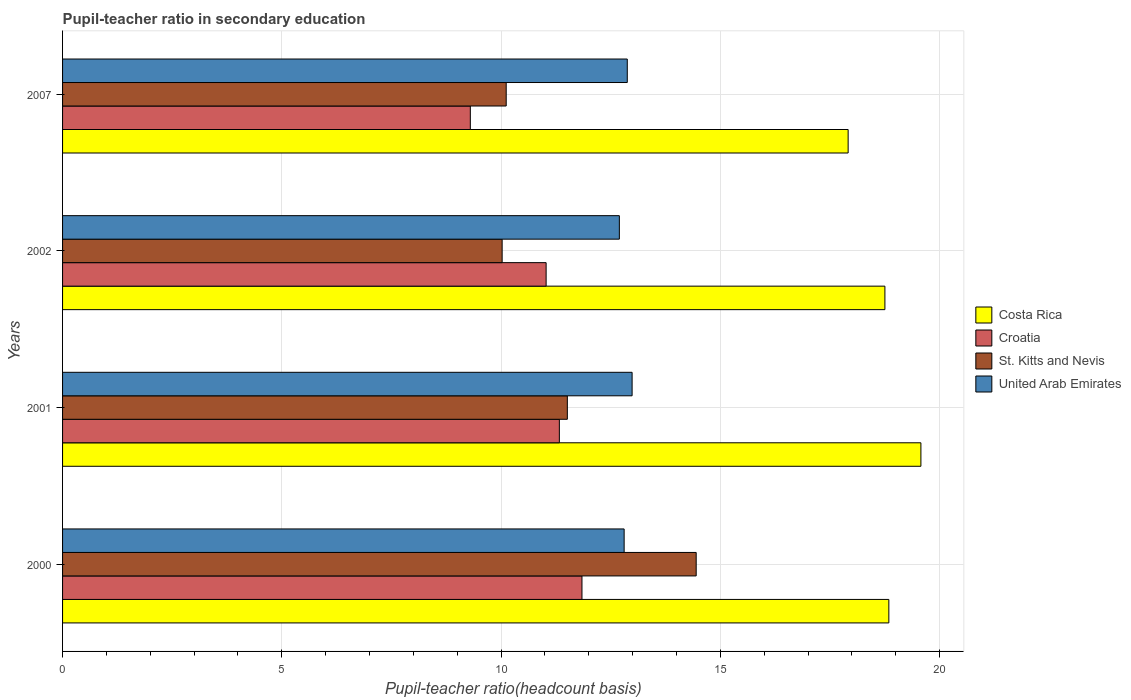How many different coloured bars are there?
Give a very brief answer. 4. How many bars are there on the 4th tick from the bottom?
Keep it short and to the point. 4. What is the label of the 3rd group of bars from the top?
Ensure brevity in your answer.  2001. In how many cases, is the number of bars for a given year not equal to the number of legend labels?
Provide a succinct answer. 0. What is the pupil-teacher ratio in secondary education in St. Kitts and Nevis in 2007?
Your answer should be compact. 10.12. Across all years, what is the maximum pupil-teacher ratio in secondary education in Croatia?
Your answer should be compact. 11.84. Across all years, what is the minimum pupil-teacher ratio in secondary education in St. Kitts and Nevis?
Your response must be concise. 10.02. What is the total pupil-teacher ratio in secondary education in United Arab Emirates in the graph?
Your answer should be compact. 51.37. What is the difference between the pupil-teacher ratio in secondary education in Costa Rica in 2000 and that in 2007?
Make the answer very short. 0.93. What is the difference between the pupil-teacher ratio in secondary education in United Arab Emirates in 2007 and the pupil-teacher ratio in secondary education in Croatia in 2001?
Ensure brevity in your answer.  1.55. What is the average pupil-teacher ratio in secondary education in Costa Rica per year?
Provide a short and direct response. 18.77. In the year 2001, what is the difference between the pupil-teacher ratio in secondary education in United Arab Emirates and pupil-teacher ratio in secondary education in St. Kitts and Nevis?
Your answer should be very brief. 1.48. In how many years, is the pupil-teacher ratio in secondary education in United Arab Emirates greater than 4 ?
Your answer should be compact. 4. What is the ratio of the pupil-teacher ratio in secondary education in Croatia in 2000 to that in 2007?
Provide a short and direct response. 1.27. Is the pupil-teacher ratio in secondary education in United Arab Emirates in 2000 less than that in 2002?
Provide a succinct answer. No. Is the difference between the pupil-teacher ratio in secondary education in United Arab Emirates in 2001 and 2007 greater than the difference between the pupil-teacher ratio in secondary education in St. Kitts and Nevis in 2001 and 2007?
Your answer should be compact. No. What is the difference between the highest and the second highest pupil-teacher ratio in secondary education in United Arab Emirates?
Your answer should be compact. 0.11. What is the difference between the highest and the lowest pupil-teacher ratio in secondary education in United Arab Emirates?
Keep it short and to the point. 0.29. In how many years, is the pupil-teacher ratio in secondary education in United Arab Emirates greater than the average pupil-teacher ratio in secondary education in United Arab Emirates taken over all years?
Your response must be concise. 2. Is it the case that in every year, the sum of the pupil-teacher ratio in secondary education in United Arab Emirates and pupil-teacher ratio in secondary education in Croatia is greater than the sum of pupil-teacher ratio in secondary education in St. Kitts and Nevis and pupil-teacher ratio in secondary education in Costa Rica?
Provide a short and direct response. Yes. What does the 1st bar from the top in 2001 represents?
Your response must be concise. United Arab Emirates. What does the 3rd bar from the bottom in 2001 represents?
Provide a short and direct response. St. Kitts and Nevis. Is it the case that in every year, the sum of the pupil-teacher ratio in secondary education in Costa Rica and pupil-teacher ratio in secondary education in Croatia is greater than the pupil-teacher ratio in secondary education in United Arab Emirates?
Your response must be concise. Yes. How many years are there in the graph?
Ensure brevity in your answer.  4. Does the graph contain grids?
Offer a terse response. Yes. How are the legend labels stacked?
Ensure brevity in your answer.  Vertical. What is the title of the graph?
Provide a short and direct response. Pupil-teacher ratio in secondary education. Does "Croatia" appear as one of the legend labels in the graph?
Offer a terse response. Yes. What is the label or title of the X-axis?
Offer a very short reply. Pupil-teacher ratio(headcount basis). What is the label or title of the Y-axis?
Offer a terse response. Years. What is the Pupil-teacher ratio(headcount basis) of Costa Rica in 2000?
Your answer should be compact. 18.84. What is the Pupil-teacher ratio(headcount basis) in Croatia in 2000?
Provide a short and direct response. 11.84. What is the Pupil-teacher ratio(headcount basis) in St. Kitts and Nevis in 2000?
Keep it short and to the point. 14.45. What is the Pupil-teacher ratio(headcount basis) of United Arab Emirates in 2000?
Your answer should be compact. 12.81. What is the Pupil-teacher ratio(headcount basis) of Costa Rica in 2001?
Your answer should be compact. 19.57. What is the Pupil-teacher ratio(headcount basis) in Croatia in 2001?
Provide a succinct answer. 11.33. What is the Pupil-teacher ratio(headcount basis) of St. Kitts and Nevis in 2001?
Offer a very short reply. 11.51. What is the Pupil-teacher ratio(headcount basis) in United Arab Emirates in 2001?
Your response must be concise. 12.99. What is the Pupil-teacher ratio(headcount basis) in Costa Rica in 2002?
Offer a terse response. 18.75. What is the Pupil-teacher ratio(headcount basis) in Croatia in 2002?
Your response must be concise. 11.03. What is the Pupil-teacher ratio(headcount basis) in St. Kitts and Nevis in 2002?
Give a very brief answer. 10.02. What is the Pupil-teacher ratio(headcount basis) of United Arab Emirates in 2002?
Offer a very short reply. 12.7. What is the Pupil-teacher ratio(headcount basis) in Costa Rica in 2007?
Keep it short and to the point. 17.91. What is the Pupil-teacher ratio(headcount basis) of Croatia in 2007?
Offer a terse response. 9.3. What is the Pupil-teacher ratio(headcount basis) in St. Kitts and Nevis in 2007?
Ensure brevity in your answer.  10.12. What is the Pupil-teacher ratio(headcount basis) in United Arab Emirates in 2007?
Provide a short and direct response. 12.88. Across all years, what is the maximum Pupil-teacher ratio(headcount basis) of Costa Rica?
Provide a succinct answer. 19.57. Across all years, what is the maximum Pupil-teacher ratio(headcount basis) of Croatia?
Provide a succinct answer. 11.84. Across all years, what is the maximum Pupil-teacher ratio(headcount basis) in St. Kitts and Nevis?
Make the answer very short. 14.45. Across all years, what is the maximum Pupil-teacher ratio(headcount basis) of United Arab Emirates?
Offer a very short reply. 12.99. Across all years, what is the minimum Pupil-teacher ratio(headcount basis) of Costa Rica?
Ensure brevity in your answer.  17.91. Across all years, what is the minimum Pupil-teacher ratio(headcount basis) of Croatia?
Give a very brief answer. 9.3. Across all years, what is the minimum Pupil-teacher ratio(headcount basis) of St. Kitts and Nevis?
Your answer should be compact. 10.02. Across all years, what is the minimum Pupil-teacher ratio(headcount basis) in United Arab Emirates?
Your answer should be compact. 12.7. What is the total Pupil-teacher ratio(headcount basis) of Costa Rica in the graph?
Give a very brief answer. 75.08. What is the total Pupil-teacher ratio(headcount basis) in Croatia in the graph?
Provide a succinct answer. 43.5. What is the total Pupil-teacher ratio(headcount basis) of St. Kitts and Nevis in the graph?
Ensure brevity in your answer.  46.1. What is the total Pupil-teacher ratio(headcount basis) of United Arab Emirates in the graph?
Make the answer very short. 51.37. What is the difference between the Pupil-teacher ratio(headcount basis) of Costa Rica in 2000 and that in 2001?
Offer a terse response. -0.73. What is the difference between the Pupil-teacher ratio(headcount basis) in Croatia in 2000 and that in 2001?
Offer a terse response. 0.52. What is the difference between the Pupil-teacher ratio(headcount basis) of St. Kitts and Nevis in 2000 and that in 2001?
Keep it short and to the point. 2.94. What is the difference between the Pupil-teacher ratio(headcount basis) in United Arab Emirates in 2000 and that in 2001?
Offer a terse response. -0.18. What is the difference between the Pupil-teacher ratio(headcount basis) of Costa Rica in 2000 and that in 2002?
Your response must be concise. 0.09. What is the difference between the Pupil-teacher ratio(headcount basis) of Croatia in 2000 and that in 2002?
Make the answer very short. 0.82. What is the difference between the Pupil-teacher ratio(headcount basis) of St. Kitts and Nevis in 2000 and that in 2002?
Keep it short and to the point. 4.42. What is the difference between the Pupil-teacher ratio(headcount basis) of United Arab Emirates in 2000 and that in 2002?
Your response must be concise. 0.11. What is the difference between the Pupil-teacher ratio(headcount basis) of Costa Rica in 2000 and that in 2007?
Keep it short and to the point. 0.93. What is the difference between the Pupil-teacher ratio(headcount basis) in Croatia in 2000 and that in 2007?
Your response must be concise. 2.55. What is the difference between the Pupil-teacher ratio(headcount basis) in St. Kitts and Nevis in 2000 and that in 2007?
Your answer should be very brief. 4.33. What is the difference between the Pupil-teacher ratio(headcount basis) in United Arab Emirates in 2000 and that in 2007?
Ensure brevity in your answer.  -0.07. What is the difference between the Pupil-teacher ratio(headcount basis) of Costa Rica in 2001 and that in 2002?
Make the answer very short. 0.82. What is the difference between the Pupil-teacher ratio(headcount basis) of Croatia in 2001 and that in 2002?
Ensure brevity in your answer.  0.3. What is the difference between the Pupil-teacher ratio(headcount basis) in St. Kitts and Nevis in 2001 and that in 2002?
Your answer should be compact. 1.49. What is the difference between the Pupil-teacher ratio(headcount basis) in United Arab Emirates in 2001 and that in 2002?
Ensure brevity in your answer.  0.29. What is the difference between the Pupil-teacher ratio(headcount basis) of Costa Rica in 2001 and that in 2007?
Ensure brevity in your answer.  1.66. What is the difference between the Pupil-teacher ratio(headcount basis) in Croatia in 2001 and that in 2007?
Offer a terse response. 2.03. What is the difference between the Pupil-teacher ratio(headcount basis) of St. Kitts and Nevis in 2001 and that in 2007?
Provide a succinct answer. 1.39. What is the difference between the Pupil-teacher ratio(headcount basis) in United Arab Emirates in 2001 and that in 2007?
Provide a short and direct response. 0.11. What is the difference between the Pupil-teacher ratio(headcount basis) of Costa Rica in 2002 and that in 2007?
Offer a terse response. 0.84. What is the difference between the Pupil-teacher ratio(headcount basis) of Croatia in 2002 and that in 2007?
Offer a very short reply. 1.73. What is the difference between the Pupil-teacher ratio(headcount basis) in St. Kitts and Nevis in 2002 and that in 2007?
Your answer should be very brief. -0.09. What is the difference between the Pupil-teacher ratio(headcount basis) of United Arab Emirates in 2002 and that in 2007?
Make the answer very short. -0.18. What is the difference between the Pupil-teacher ratio(headcount basis) of Costa Rica in 2000 and the Pupil-teacher ratio(headcount basis) of Croatia in 2001?
Your answer should be very brief. 7.51. What is the difference between the Pupil-teacher ratio(headcount basis) in Costa Rica in 2000 and the Pupil-teacher ratio(headcount basis) in St. Kitts and Nevis in 2001?
Provide a short and direct response. 7.33. What is the difference between the Pupil-teacher ratio(headcount basis) of Costa Rica in 2000 and the Pupil-teacher ratio(headcount basis) of United Arab Emirates in 2001?
Your response must be concise. 5.85. What is the difference between the Pupil-teacher ratio(headcount basis) in Croatia in 2000 and the Pupil-teacher ratio(headcount basis) in St. Kitts and Nevis in 2001?
Ensure brevity in your answer.  0.33. What is the difference between the Pupil-teacher ratio(headcount basis) of Croatia in 2000 and the Pupil-teacher ratio(headcount basis) of United Arab Emirates in 2001?
Make the answer very short. -1.14. What is the difference between the Pupil-teacher ratio(headcount basis) of St. Kitts and Nevis in 2000 and the Pupil-teacher ratio(headcount basis) of United Arab Emirates in 2001?
Make the answer very short. 1.46. What is the difference between the Pupil-teacher ratio(headcount basis) of Costa Rica in 2000 and the Pupil-teacher ratio(headcount basis) of Croatia in 2002?
Provide a short and direct response. 7.82. What is the difference between the Pupil-teacher ratio(headcount basis) of Costa Rica in 2000 and the Pupil-teacher ratio(headcount basis) of St. Kitts and Nevis in 2002?
Offer a terse response. 8.82. What is the difference between the Pupil-teacher ratio(headcount basis) of Costa Rica in 2000 and the Pupil-teacher ratio(headcount basis) of United Arab Emirates in 2002?
Make the answer very short. 6.14. What is the difference between the Pupil-teacher ratio(headcount basis) in Croatia in 2000 and the Pupil-teacher ratio(headcount basis) in St. Kitts and Nevis in 2002?
Ensure brevity in your answer.  1.82. What is the difference between the Pupil-teacher ratio(headcount basis) in Croatia in 2000 and the Pupil-teacher ratio(headcount basis) in United Arab Emirates in 2002?
Make the answer very short. -0.85. What is the difference between the Pupil-teacher ratio(headcount basis) of St. Kitts and Nevis in 2000 and the Pupil-teacher ratio(headcount basis) of United Arab Emirates in 2002?
Keep it short and to the point. 1.75. What is the difference between the Pupil-teacher ratio(headcount basis) of Costa Rica in 2000 and the Pupil-teacher ratio(headcount basis) of Croatia in 2007?
Make the answer very short. 9.54. What is the difference between the Pupil-teacher ratio(headcount basis) in Costa Rica in 2000 and the Pupil-teacher ratio(headcount basis) in St. Kitts and Nevis in 2007?
Offer a very short reply. 8.73. What is the difference between the Pupil-teacher ratio(headcount basis) of Costa Rica in 2000 and the Pupil-teacher ratio(headcount basis) of United Arab Emirates in 2007?
Keep it short and to the point. 5.96. What is the difference between the Pupil-teacher ratio(headcount basis) of Croatia in 2000 and the Pupil-teacher ratio(headcount basis) of St. Kitts and Nevis in 2007?
Your response must be concise. 1.73. What is the difference between the Pupil-teacher ratio(headcount basis) in Croatia in 2000 and the Pupil-teacher ratio(headcount basis) in United Arab Emirates in 2007?
Provide a succinct answer. -1.03. What is the difference between the Pupil-teacher ratio(headcount basis) of St. Kitts and Nevis in 2000 and the Pupil-teacher ratio(headcount basis) of United Arab Emirates in 2007?
Make the answer very short. 1.57. What is the difference between the Pupil-teacher ratio(headcount basis) in Costa Rica in 2001 and the Pupil-teacher ratio(headcount basis) in Croatia in 2002?
Provide a short and direct response. 8.55. What is the difference between the Pupil-teacher ratio(headcount basis) in Costa Rica in 2001 and the Pupil-teacher ratio(headcount basis) in St. Kitts and Nevis in 2002?
Offer a terse response. 9.55. What is the difference between the Pupil-teacher ratio(headcount basis) of Costa Rica in 2001 and the Pupil-teacher ratio(headcount basis) of United Arab Emirates in 2002?
Keep it short and to the point. 6.88. What is the difference between the Pupil-teacher ratio(headcount basis) in Croatia in 2001 and the Pupil-teacher ratio(headcount basis) in St. Kitts and Nevis in 2002?
Keep it short and to the point. 1.3. What is the difference between the Pupil-teacher ratio(headcount basis) of Croatia in 2001 and the Pupil-teacher ratio(headcount basis) of United Arab Emirates in 2002?
Make the answer very short. -1.37. What is the difference between the Pupil-teacher ratio(headcount basis) of St. Kitts and Nevis in 2001 and the Pupil-teacher ratio(headcount basis) of United Arab Emirates in 2002?
Ensure brevity in your answer.  -1.19. What is the difference between the Pupil-teacher ratio(headcount basis) of Costa Rica in 2001 and the Pupil-teacher ratio(headcount basis) of Croatia in 2007?
Your answer should be very brief. 10.27. What is the difference between the Pupil-teacher ratio(headcount basis) in Costa Rica in 2001 and the Pupil-teacher ratio(headcount basis) in St. Kitts and Nevis in 2007?
Offer a very short reply. 9.46. What is the difference between the Pupil-teacher ratio(headcount basis) of Costa Rica in 2001 and the Pupil-teacher ratio(headcount basis) of United Arab Emirates in 2007?
Your answer should be very brief. 6.7. What is the difference between the Pupil-teacher ratio(headcount basis) of Croatia in 2001 and the Pupil-teacher ratio(headcount basis) of St. Kitts and Nevis in 2007?
Provide a short and direct response. 1.21. What is the difference between the Pupil-teacher ratio(headcount basis) in Croatia in 2001 and the Pupil-teacher ratio(headcount basis) in United Arab Emirates in 2007?
Keep it short and to the point. -1.55. What is the difference between the Pupil-teacher ratio(headcount basis) in St. Kitts and Nevis in 2001 and the Pupil-teacher ratio(headcount basis) in United Arab Emirates in 2007?
Your response must be concise. -1.37. What is the difference between the Pupil-teacher ratio(headcount basis) of Costa Rica in 2002 and the Pupil-teacher ratio(headcount basis) of Croatia in 2007?
Give a very brief answer. 9.45. What is the difference between the Pupil-teacher ratio(headcount basis) in Costa Rica in 2002 and the Pupil-teacher ratio(headcount basis) in St. Kitts and Nevis in 2007?
Make the answer very short. 8.64. What is the difference between the Pupil-teacher ratio(headcount basis) in Costa Rica in 2002 and the Pupil-teacher ratio(headcount basis) in United Arab Emirates in 2007?
Your response must be concise. 5.87. What is the difference between the Pupil-teacher ratio(headcount basis) in Croatia in 2002 and the Pupil-teacher ratio(headcount basis) in St. Kitts and Nevis in 2007?
Give a very brief answer. 0.91. What is the difference between the Pupil-teacher ratio(headcount basis) in Croatia in 2002 and the Pupil-teacher ratio(headcount basis) in United Arab Emirates in 2007?
Your answer should be very brief. -1.85. What is the difference between the Pupil-teacher ratio(headcount basis) in St. Kitts and Nevis in 2002 and the Pupil-teacher ratio(headcount basis) in United Arab Emirates in 2007?
Offer a terse response. -2.85. What is the average Pupil-teacher ratio(headcount basis) of Costa Rica per year?
Your response must be concise. 18.77. What is the average Pupil-teacher ratio(headcount basis) in Croatia per year?
Provide a succinct answer. 10.87. What is the average Pupil-teacher ratio(headcount basis) of St. Kitts and Nevis per year?
Make the answer very short. 11.52. What is the average Pupil-teacher ratio(headcount basis) in United Arab Emirates per year?
Keep it short and to the point. 12.84. In the year 2000, what is the difference between the Pupil-teacher ratio(headcount basis) in Costa Rica and Pupil-teacher ratio(headcount basis) in Croatia?
Your answer should be very brief. 7. In the year 2000, what is the difference between the Pupil-teacher ratio(headcount basis) of Costa Rica and Pupil-teacher ratio(headcount basis) of St. Kitts and Nevis?
Make the answer very short. 4.39. In the year 2000, what is the difference between the Pupil-teacher ratio(headcount basis) in Costa Rica and Pupil-teacher ratio(headcount basis) in United Arab Emirates?
Provide a short and direct response. 6.04. In the year 2000, what is the difference between the Pupil-teacher ratio(headcount basis) of Croatia and Pupil-teacher ratio(headcount basis) of St. Kitts and Nevis?
Your answer should be very brief. -2.6. In the year 2000, what is the difference between the Pupil-teacher ratio(headcount basis) in Croatia and Pupil-teacher ratio(headcount basis) in United Arab Emirates?
Your response must be concise. -0.96. In the year 2000, what is the difference between the Pupil-teacher ratio(headcount basis) of St. Kitts and Nevis and Pupil-teacher ratio(headcount basis) of United Arab Emirates?
Keep it short and to the point. 1.64. In the year 2001, what is the difference between the Pupil-teacher ratio(headcount basis) of Costa Rica and Pupil-teacher ratio(headcount basis) of Croatia?
Provide a succinct answer. 8.24. In the year 2001, what is the difference between the Pupil-teacher ratio(headcount basis) in Costa Rica and Pupil-teacher ratio(headcount basis) in St. Kitts and Nevis?
Offer a terse response. 8.06. In the year 2001, what is the difference between the Pupil-teacher ratio(headcount basis) in Costa Rica and Pupil-teacher ratio(headcount basis) in United Arab Emirates?
Keep it short and to the point. 6.59. In the year 2001, what is the difference between the Pupil-teacher ratio(headcount basis) in Croatia and Pupil-teacher ratio(headcount basis) in St. Kitts and Nevis?
Offer a very short reply. -0.18. In the year 2001, what is the difference between the Pupil-teacher ratio(headcount basis) of Croatia and Pupil-teacher ratio(headcount basis) of United Arab Emirates?
Your answer should be very brief. -1.66. In the year 2001, what is the difference between the Pupil-teacher ratio(headcount basis) in St. Kitts and Nevis and Pupil-teacher ratio(headcount basis) in United Arab Emirates?
Ensure brevity in your answer.  -1.48. In the year 2002, what is the difference between the Pupil-teacher ratio(headcount basis) of Costa Rica and Pupil-teacher ratio(headcount basis) of Croatia?
Offer a terse response. 7.73. In the year 2002, what is the difference between the Pupil-teacher ratio(headcount basis) of Costa Rica and Pupil-teacher ratio(headcount basis) of St. Kitts and Nevis?
Your answer should be very brief. 8.73. In the year 2002, what is the difference between the Pupil-teacher ratio(headcount basis) in Costa Rica and Pupil-teacher ratio(headcount basis) in United Arab Emirates?
Make the answer very short. 6.06. In the year 2002, what is the difference between the Pupil-teacher ratio(headcount basis) of Croatia and Pupil-teacher ratio(headcount basis) of United Arab Emirates?
Keep it short and to the point. -1.67. In the year 2002, what is the difference between the Pupil-teacher ratio(headcount basis) in St. Kitts and Nevis and Pupil-teacher ratio(headcount basis) in United Arab Emirates?
Ensure brevity in your answer.  -2.67. In the year 2007, what is the difference between the Pupil-teacher ratio(headcount basis) of Costa Rica and Pupil-teacher ratio(headcount basis) of Croatia?
Provide a succinct answer. 8.62. In the year 2007, what is the difference between the Pupil-teacher ratio(headcount basis) in Costa Rica and Pupil-teacher ratio(headcount basis) in St. Kitts and Nevis?
Offer a very short reply. 7.8. In the year 2007, what is the difference between the Pupil-teacher ratio(headcount basis) of Costa Rica and Pupil-teacher ratio(headcount basis) of United Arab Emirates?
Ensure brevity in your answer.  5.04. In the year 2007, what is the difference between the Pupil-teacher ratio(headcount basis) in Croatia and Pupil-teacher ratio(headcount basis) in St. Kitts and Nevis?
Make the answer very short. -0.82. In the year 2007, what is the difference between the Pupil-teacher ratio(headcount basis) of Croatia and Pupil-teacher ratio(headcount basis) of United Arab Emirates?
Keep it short and to the point. -3.58. In the year 2007, what is the difference between the Pupil-teacher ratio(headcount basis) in St. Kitts and Nevis and Pupil-teacher ratio(headcount basis) in United Arab Emirates?
Ensure brevity in your answer.  -2.76. What is the ratio of the Pupil-teacher ratio(headcount basis) of Costa Rica in 2000 to that in 2001?
Provide a succinct answer. 0.96. What is the ratio of the Pupil-teacher ratio(headcount basis) of Croatia in 2000 to that in 2001?
Offer a terse response. 1.05. What is the ratio of the Pupil-teacher ratio(headcount basis) of St. Kitts and Nevis in 2000 to that in 2001?
Provide a succinct answer. 1.26. What is the ratio of the Pupil-teacher ratio(headcount basis) in United Arab Emirates in 2000 to that in 2001?
Provide a succinct answer. 0.99. What is the ratio of the Pupil-teacher ratio(headcount basis) of Costa Rica in 2000 to that in 2002?
Your answer should be very brief. 1. What is the ratio of the Pupil-teacher ratio(headcount basis) in Croatia in 2000 to that in 2002?
Provide a short and direct response. 1.07. What is the ratio of the Pupil-teacher ratio(headcount basis) of St. Kitts and Nevis in 2000 to that in 2002?
Ensure brevity in your answer.  1.44. What is the ratio of the Pupil-teacher ratio(headcount basis) in United Arab Emirates in 2000 to that in 2002?
Offer a very short reply. 1.01. What is the ratio of the Pupil-teacher ratio(headcount basis) of Costa Rica in 2000 to that in 2007?
Give a very brief answer. 1.05. What is the ratio of the Pupil-teacher ratio(headcount basis) in Croatia in 2000 to that in 2007?
Offer a very short reply. 1.27. What is the ratio of the Pupil-teacher ratio(headcount basis) in St. Kitts and Nevis in 2000 to that in 2007?
Make the answer very short. 1.43. What is the ratio of the Pupil-teacher ratio(headcount basis) in United Arab Emirates in 2000 to that in 2007?
Ensure brevity in your answer.  0.99. What is the ratio of the Pupil-teacher ratio(headcount basis) in Costa Rica in 2001 to that in 2002?
Offer a very short reply. 1.04. What is the ratio of the Pupil-teacher ratio(headcount basis) of Croatia in 2001 to that in 2002?
Provide a succinct answer. 1.03. What is the ratio of the Pupil-teacher ratio(headcount basis) in St. Kitts and Nevis in 2001 to that in 2002?
Offer a very short reply. 1.15. What is the ratio of the Pupil-teacher ratio(headcount basis) in United Arab Emirates in 2001 to that in 2002?
Offer a very short reply. 1.02. What is the ratio of the Pupil-teacher ratio(headcount basis) in Costa Rica in 2001 to that in 2007?
Ensure brevity in your answer.  1.09. What is the ratio of the Pupil-teacher ratio(headcount basis) of Croatia in 2001 to that in 2007?
Your response must be concise. 1.22. What is the ratio of the Pupil-teacher ratio(headcount basis) in St. Kitts and Nevis in 2001 to that in 2007?
Provide a short and direct response. 1.14. What is the ratio of the Pupil-teacher ratio(headcount basis) of United Arab Emirates in 2001 to that in 2007?
Keep it short and to the point. 1.01. What is the ratio of the Pupil-teacher ratio(headcount basis) in Costa Rica in 2002 to that in 2007?
Ensure brevity in your answer.  1.05. What is the ratio of the Pupil-teacher ratio(headcount basis) of Croatia in 2002 to that in 2007?
Provide a short and direct response. 1.19. What is the difference between the highest and the second highest Pupil-teacher ratio(headcount basis) in Costa Rica?
Offer a very short reply. 0.73. What is the difference between the highest and the second highest Pupil-teacher ratio(headcount basis) in Croatia?
Offer a very short reply. 0.52. What is the difference between the highest and the second highest Pupil-teacher ratio(headcount basis) in St. Kitts and Nevis?
Your answer should be very brief. 2.94. What is the difference between the highest and the second highest Pupil-teacher ratio(headcount basis) in United Arab Emirates?
Your response must be concise. 0.11. What is the difference between the highest and the lowest Pupil-teacher ratio(headcount basis) of Costa Rica?
Ensure brevity in your answer.  1.66. What is the difference between the highest and the lowest Pupil-teacher ratio(headcount basis) in Croatia?
Offer a very short reply. 2.55. What is the difference between the highest and the lowest Pupil-teacher ratio(headcount basis) in St. Kitts and Nevis?
Ensure brevity in your answer.  4.42. What is the difference between the highest and the lowest Pupil-teacher ratio(headcount basis) in United Arab Emirates?
Keep it short and to the point. 0.29. 